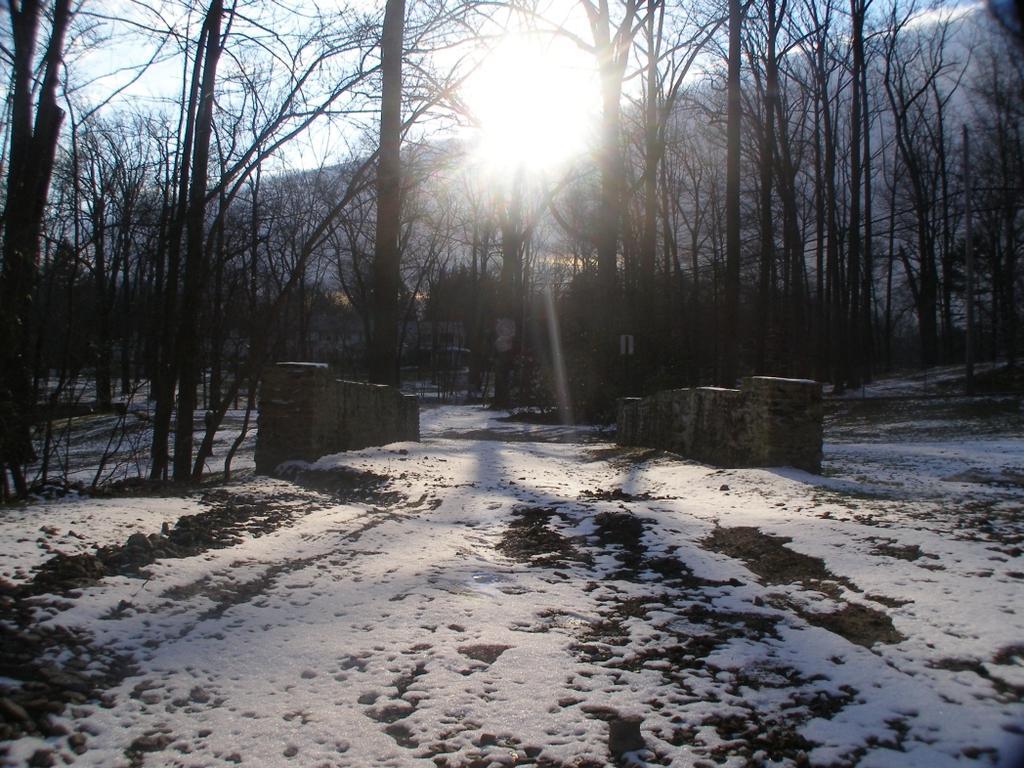Could you give a brief overview of what you see in this image? In this picture we can see snow on the ground, trees and in the background we can see the sky. 